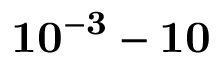Convert formula to latex. <formula><loc_0><loc_0><loc_500><loc_500>1 0 ^ { - 3 } - 1 0</formula> 